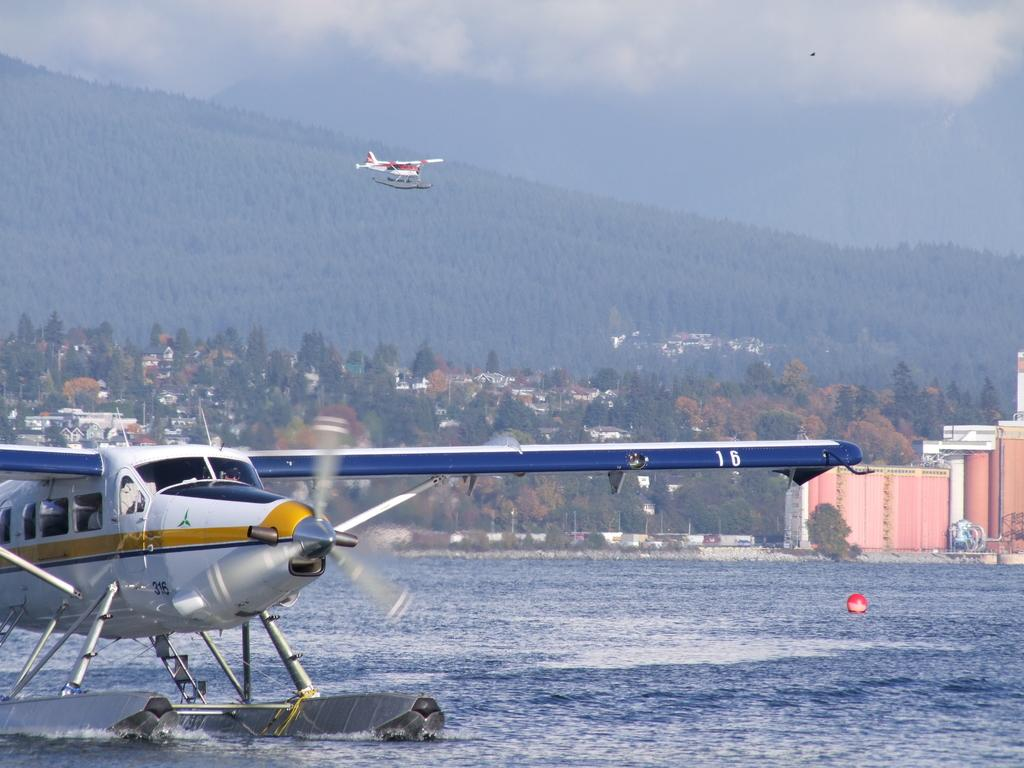What is visible in the image? There is water visible in the image. What else can be seen in the image besides the water? There are two aircraft, buildings, trees, and clouds in the sky in the background of the image. Can you describe the aircraft in the image? There are two aircraft in the image, but their specific details cannot be determined from the provided facts. What type of natural environment is visible in the image? The image features a combination of natural elements, including water, trees, and clouds. What type of lead can be seen connecting the two aircraft in the image? There is no lead connecting the two aircraft in the image, as they are separate entities. 